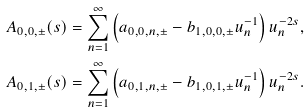Convert formula to latex. <formula><loc_0><loc_0><loc_500><loc_500>A _ { 0 , 0 , \pm } ( s ) & = \sum _ { n = 1 } ^ { \infty } \left ( a _ { 0 , 0 , n , \pm } - b _ { 1 , 0 , 0 , \pm } u _ { n } ^ { - 1 } \right ) u _ { n } ^ { - 2 s } , \\ A _ { 0 , 1 , \pm } ( s ) & = \sum _ { n = 1 } ^ { \infty } \left ( a _ { 0 , 1 , n , \pm } - b _ { 1 , 0 , 1 , \pm } u _ { n } ^ { - 1 } \right ) u _ { n } ^ { - 2 s } .</formula> 